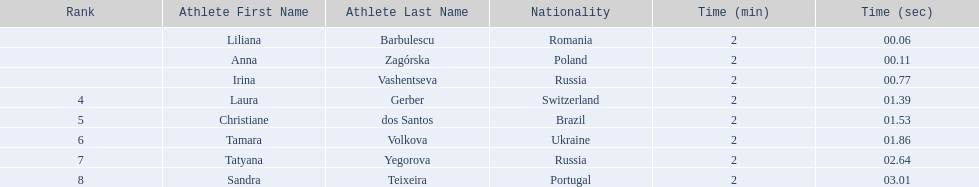What athletes are in the top five for the women's 800 metres? Liliana Barbulescu, Anna Zagórska, Irina Vashentseva, Laura Gerber, Christiane dos Santos. Which athletes are in the top 3? Liliana Barbulescu, Anna Zagórska, Irina Vashentseva. Who is the second place runner in the women's 800 metres? Anna Zagórska. What is the second place runner's time? 2:00.11. 